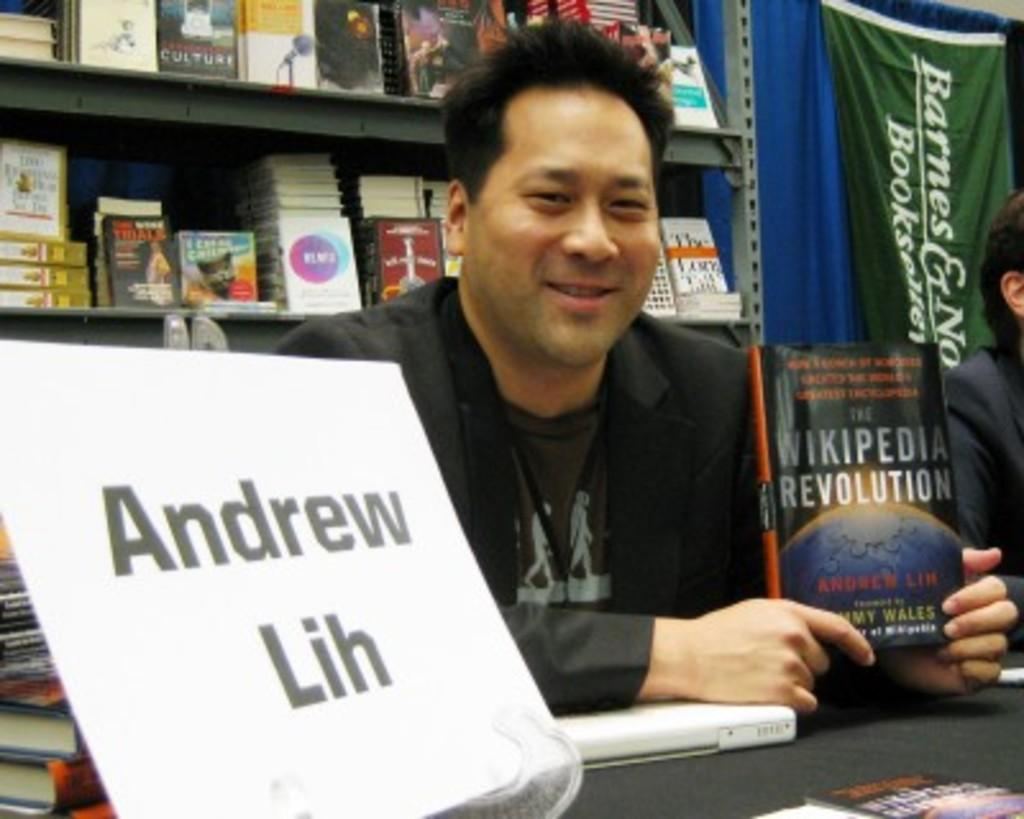<image>
Describe the image concisely. The name of the man holding the book up is Andrew Lih. 